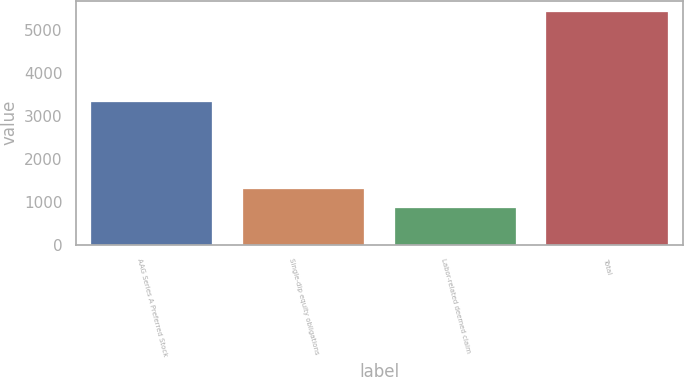<chart> <loc_0><loc_0><loc_500><loc_500><bar_chart><fcel>AAG Series A Preferred Stock<fcel>Single-dip equity obligations<fcel>Labor-related deemed claim<fcel>Total<nl><fcel>3329<fcel>1306.5<fcel>849<fcel>5424<nl></chart> 